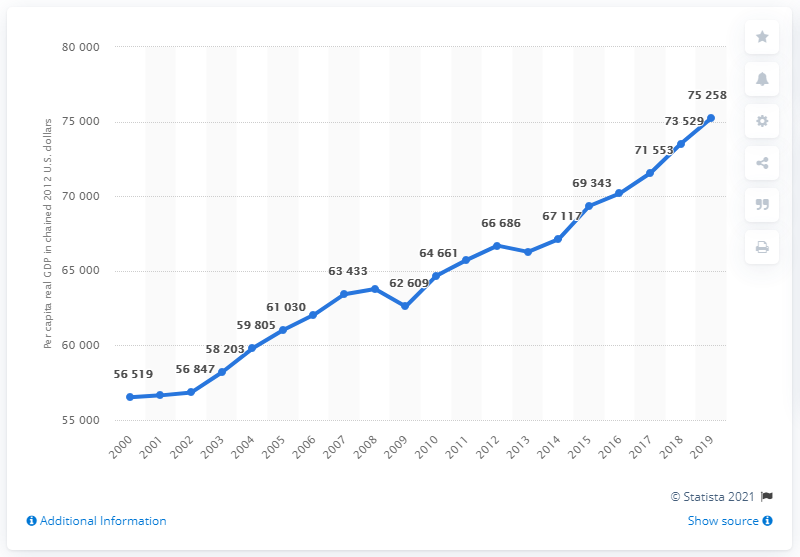List a handful of essential elements in this visual. In 2012, the per capita real GDP of Massachusetts was chain-linked. 